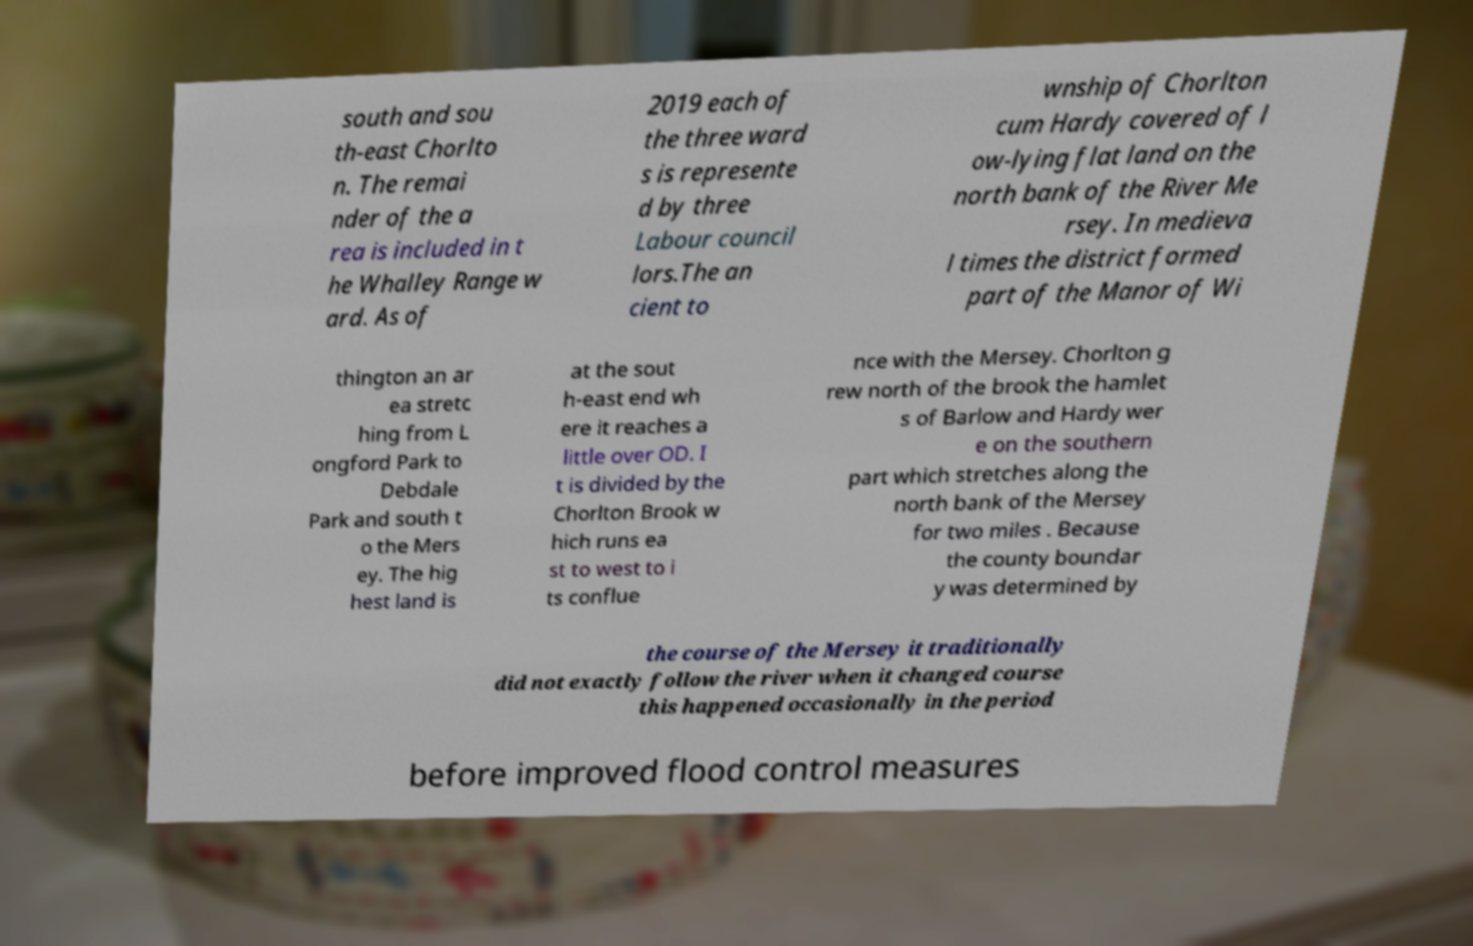Can you accurately transcribe the text from the provided image for me? south and sou th-east Chorlto n. The remai nder of the a rea is included in t he Whalley Range w ard. As of 2019 each of the three ward s is represente d by three Labour council lors.The an cient to wnship of Chorlton cum Hardy covered of l ow-lying flat land on the north bank of the River Me rsey. In medieva l times the district formed part of the Manor of Wi thington an ar ea stretc hing from L ongford Park to Debdale Park and south t o the Mers ey. The hig hest land is at the sout h-east end wh ere it reaches a little over OD. I t is divided by the Chorlton Brook w hich runs ea st to west to i ts conflue nce with the Mersey. Chorlton g rew north of the brook the hamlet s of Barlow and Hardy wer e on the southern part which stretches along the north bank of the Mersey for two miles . Because the county boundar y was determined by the course of the Mersey it traditionally did not exactly follow the river when it changed course this happened occasionally in the period before improved flood control measures 